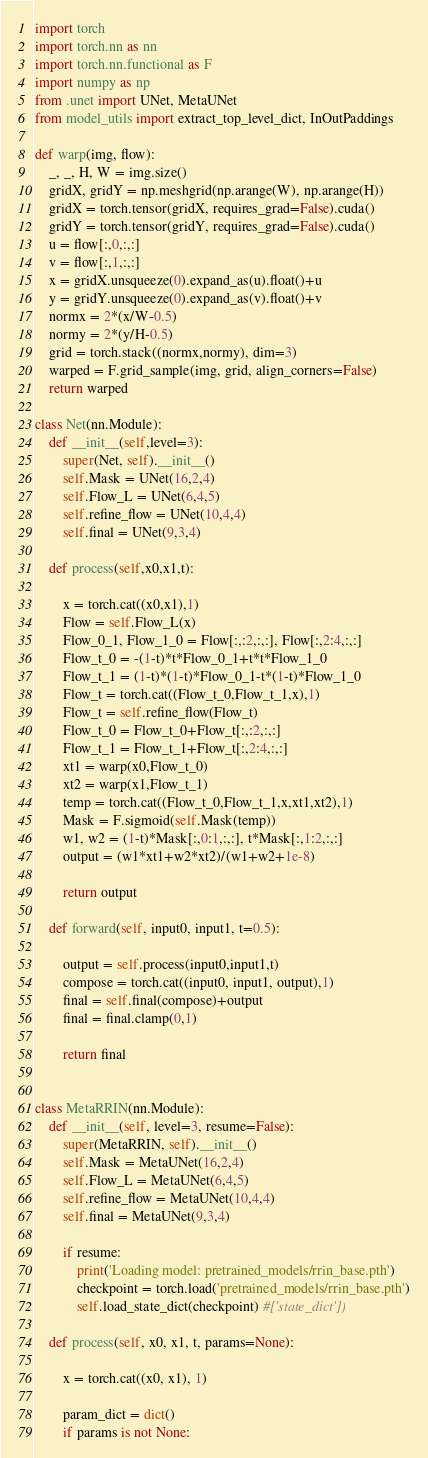Convert code to text. <code><loc_0><loc_0><loc_500><loc_500><_Python_>import torch
import torch.nn as nn
import torch.nn.functional as F
import numpy as np
from .unet import UNet, MetaUNet
from model_utils import extract_top_level_dict, InOutPaddings

def warp(img, flow):
    _, _, H, W = img.size()
    gridX, gridY = np.meshgrid(np.arange(W), np.arange(H))
    gridX = torch.tensor(gridX, requires_grad=False).cuda()
    gridY = torch.tensor(gridY, requires_grad=False).cuda()
    u = flow[:,0,:,:]
    v = flow[:,1,:,:]
    x = gridX.unsqueeze(0).expand_as(u).float()+u
    y = gridY.unsqueeze(0).expand_as(v).float()+v
    normx = 2*(x/W-0.5)
    normy = 2*(y/H-0.5)
    grid = torch.stack((normx,normy), dim=3)
    warped = F.grid_sample(img, grid, align_corners=False)
    return warped

class Net(nn.Module):
    def __init__(self,level=3):
        super(Net, self).__init__()
        self.Mask = UNet(16,2,4)
        self.Flow_L = UNet(6,4,5)
        self.refine_flow = UNet(10,4,4)
        self.final = UNet(9,3,4)

    def process(self,x0,x1,t):

        x = torch.cat((x0,x1),1)
        Flow = self.Flow_L(x)
        Flow_0_1, Flow_1_0 = Flow[:,:2,:,:], Flow[:,2:4,:,:]
        Flow_t_0 = -(1-t)*t*Flow_0_1+t*t*Flow_1_0
        Flow_t_1 = (1-t)*(1-t)*Flow_0_1-t*(1-t)*Flow_1_0
        Flow_t = torch.cat((Flow_t_0,Flow_t_1,x),1)
        Flow_t = self.refine_flow(Flow_t)
        Flow_t_0 = Flow_t_0+Flow_t[:,:2,:,:]
        Flow_t_1 = Flow_t_1+Flow_t[:,2:4,:,:]
        xt1 = warp(x0,Flow_t_0)
        xt2 = warp(x1,Flow_t_1)
        temp = torch.cat((Flow_t_0,Flow_t_1,x,xt1,xt2),1)
        Mask = F.sigmoid(self.Mask(temp))
        w1, w2 = (1-t)*Mask[:,0:1,:,:], t*Mask[:,1:2,:,:]
        output = (w1*xt1+w2*xt2)/(w1+w2+1e-8)

        return output

    def forward(self, input0, input1, t=0.5):

        output = self.process(input0,input1,t)
        compose = torch.cat((input0, input1, output),1)
        final = self.final(compose)+output
        final = final.clamp(0,1)

        return final


class MetaRRIN(nn.Module):
    def __init__(self, level=3, resume=False):
        super(MetaRRIN, self).__init__()
        self.Mask = MetaUNet(16,2,4)
        self.Flow_L = MetaUNet(6,4,5)
        self.refine_flow = MetaUNet(10,4,4)
        self.final = MetaUNet(9,3,4)

        if resume:
            print('Loading model: pretrained_models/rrin_base.pth')
            checkpoint = torch.load('pretrained_models/rrin_base.pth')
            self.load_state_dict(checkpoint) #['state_dict'])

    def process(self, x0, x1, t, params=None):

        x = torch.cat((x0, x1), 1)

        param_dict = dict()
        if params is not None:</code> 